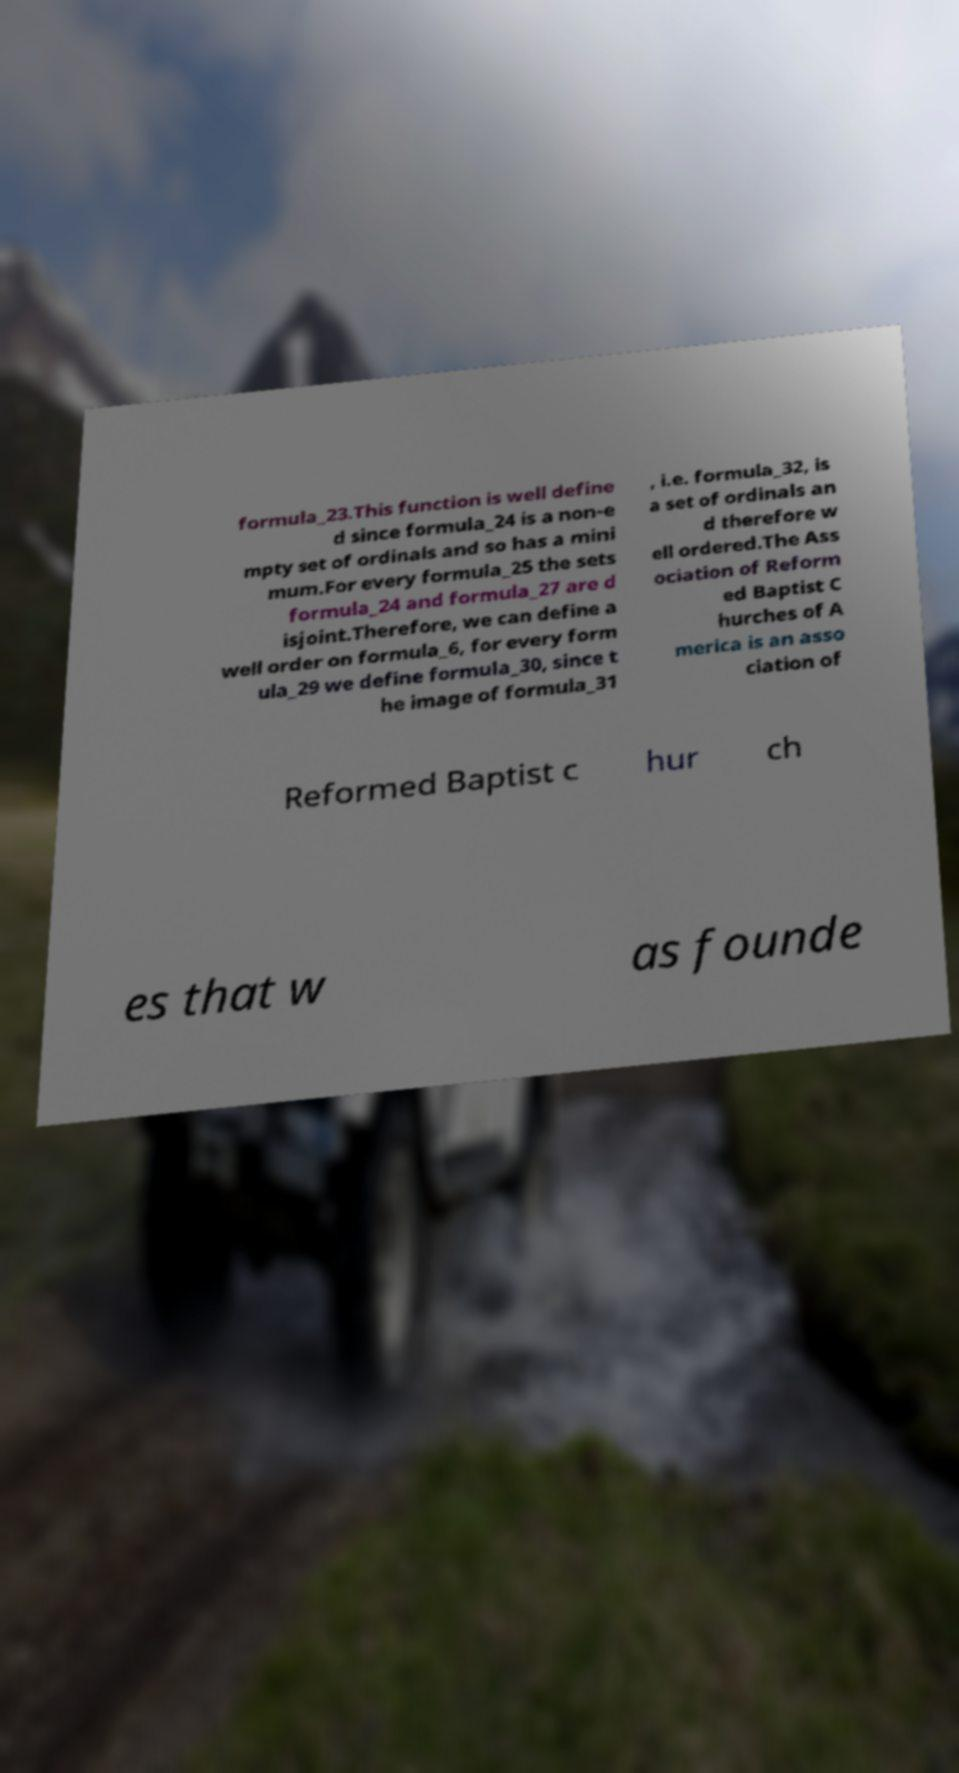I need the written content from this picture converted into text. Can you do that? formula_23.This function is well define d since formula_24 is a non-e mpty set of ordinals and so has a mini mum.For every formula_25 the sets formula_24 and formula_27 are d isjoint.Therefore, we can define a well order on formula_6, for every form ula_29 we define formula_30, since t he image of formula_31 , i.e. formula_32, is a set of ordinals an d therefore w ell ordered.The Ass ociation of Reform ed Baptist C hurches of A merica is an asso ciation of Reformed Baptist c hur ch es that w as founde 